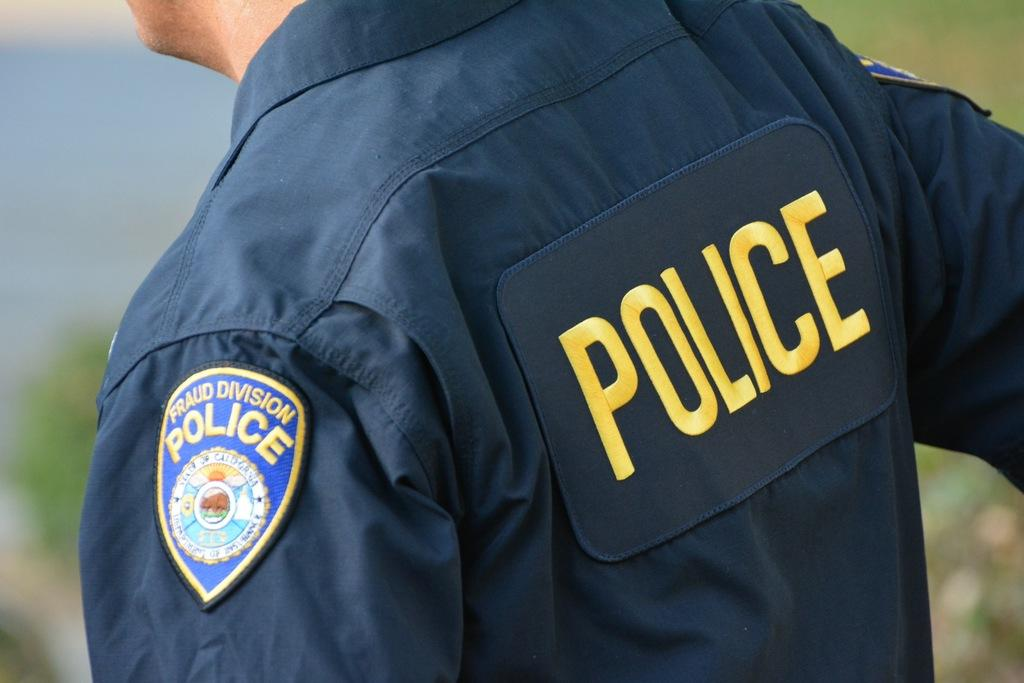<image>
Provide a brief description of the given image. A police officer that works in the fraud division. 